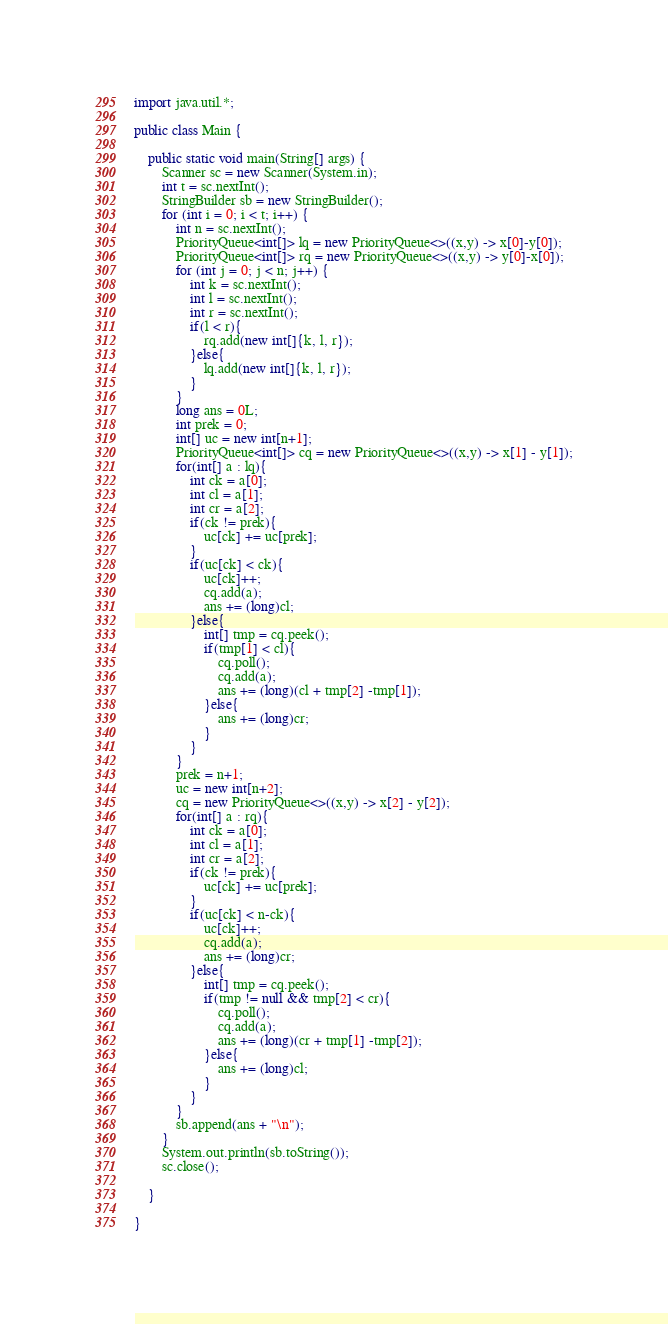Convert code to text. <code><loc_0><loc_0><loc_500><loc_500><_Java_>import java.util.*;

public class Main {

    public static void main(String[] args) {
        Scanner sc = new Scanner(System.in);
        int t = sc.nextInt();
        StringBuilder sb = new StringBuilder();
        for (int i = 0; i < t; i++) {
            int n = sc.nextInt();
            PriorityQueue<int[]> lq = new PriorityQueue<>((x,y) -> x[0]-y[0]);
            PriorityQueue<int[]> rq = new PriorityQueue<>((x,y) -> y[0]-x[0]);
            for (int j = 0; j < n; j++) {
                int k = sc.nextInt();
                int l = sc.nextInt();
                int r = sc.nextInt();
                if(l < r){
                    rq.add(new int[]{k, l, r});
                }else{
                    lq.add(new int[]{k, l, r});
                }
            }
            long ans = 0L;
            int prek = 0;
            int[] uc = new int[n+1];
            PriorityQueue<int[]> cq = new PriorityQueue<>((x,y) -> x[1] - y[1]);
            for(int[] a : lq){
                int ck = a[0];
                int cl = a[1];
                int cr = a[2];
                if(ck != prek){
                    uc[ck] += uc[prek];
                }
                if(uc[ck] < ck){
                    uc[ck]++;
                    cq.add(a);
                    ans += (long)cl;
                }else{
                    int[] tmp = cq.peek();
                    if(tmp[1] < cl){
                        cq.poll();
                        cq.add(a);
                        ans += (long)(cl + tmp[2] -tmp[1]);
                    }else{
                        ans += (long)cr;
                    }
                }
            }
            prek = n+1;
            uc = new int[n+2];
            cq = new PriorityQueue<>((x,y) -> x[2] - y[2]);
            for(int[] a : rq){
                int ck = a[0];
                int cl = a[1];
                int cr = a[2];
                if(ck != prek){
                    uc[ck] += uc[prek];
                }
                if(uc[ck] < n-ck){
                    uc[ck]++;
                    cq.add(a);
                    ans += (long)cr;
                }else{
                    int[] tmp = cq.peek();
                    if(tmp != null && tmp[2] < cr){
                        cq.poll();
                        cq.add(a);
                        ans += (long)(cr + tmp[1] -tmp[2]);
                    }else{
                        ans += (long)cl;
                    }
                }
            }
            sb.append(ans + "\n");
        }
        System.out.println(sb.toString());
        sc.close();

    }

}

</code> 